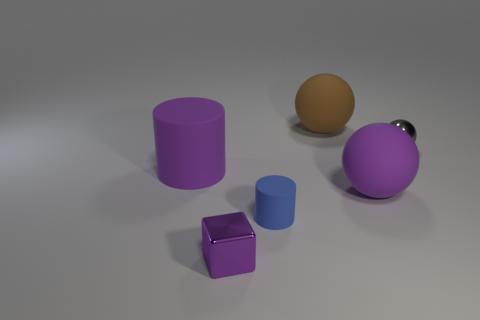Add 3 small brown metal balls. How many objects exist? 9 Subtract all cubes. How many objects are left? 5 Add 6 matte things. How many matte things are left? 10 Add 2 big yellow shiny cubes. How many big yellow shiny cubes exist? 2 Subtract 1 purple cylinders. How many objects are left? 5 Subtract all big purple rubber cylinders. Subtract all tiny purple metallic things. How many objects are left? 4 